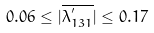<formula> <loc_0><loc_0><loc_500><loc_500>0 . 0 6 \leq | \overline { { { \lambda _ { 1 3 1 } ^ { ^ { \prime } } } } } | \leq 0 . 1 7</formula> 